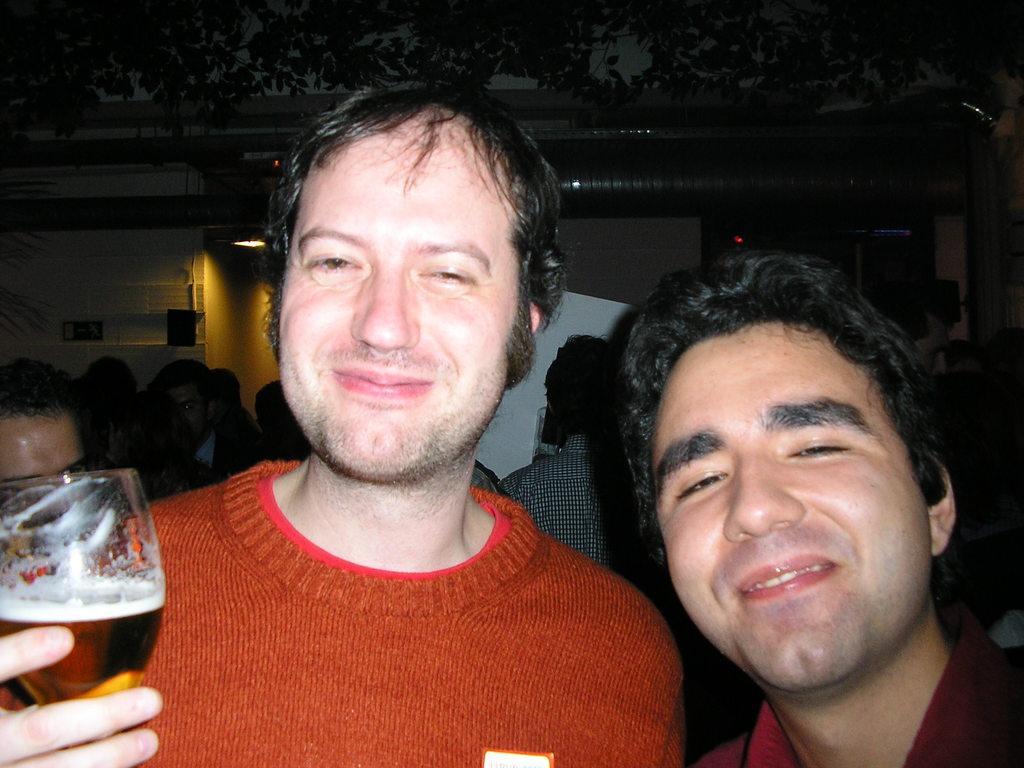In one or two sentences, can you explain what this image depicts? In this image I see 2 men who are smiling and this man is holding a glass, In the background I see few people and a tree over here. 